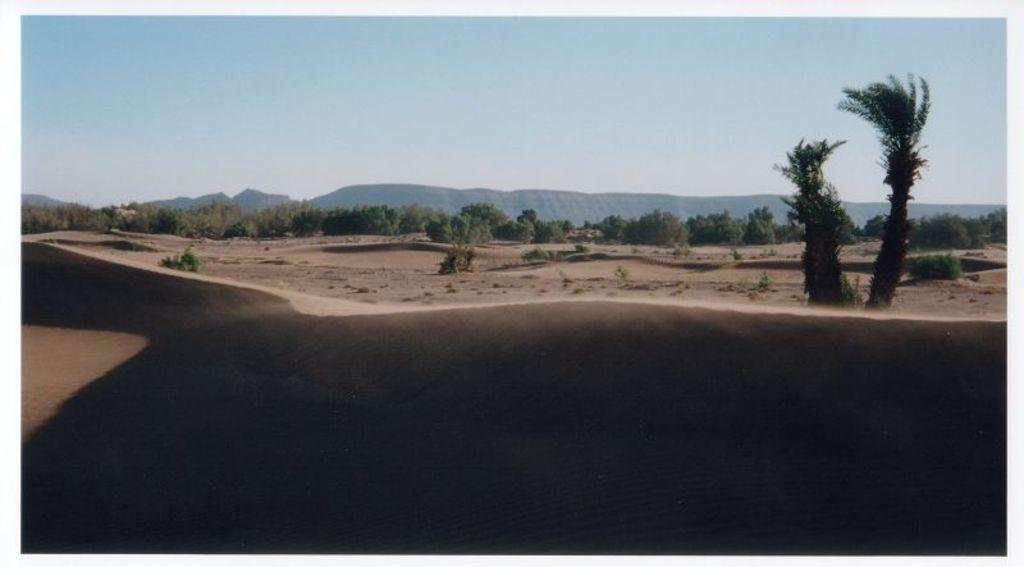What type of terrain is visible in the image? There is sand visible in the image. What can be seen in the background of the image? There are trees and mountains in the background of the image. How many eyes can be seen in the image? There are no eyes visible in the image. What type of birds can be seen flying in the image? There are no birds present in the image. 